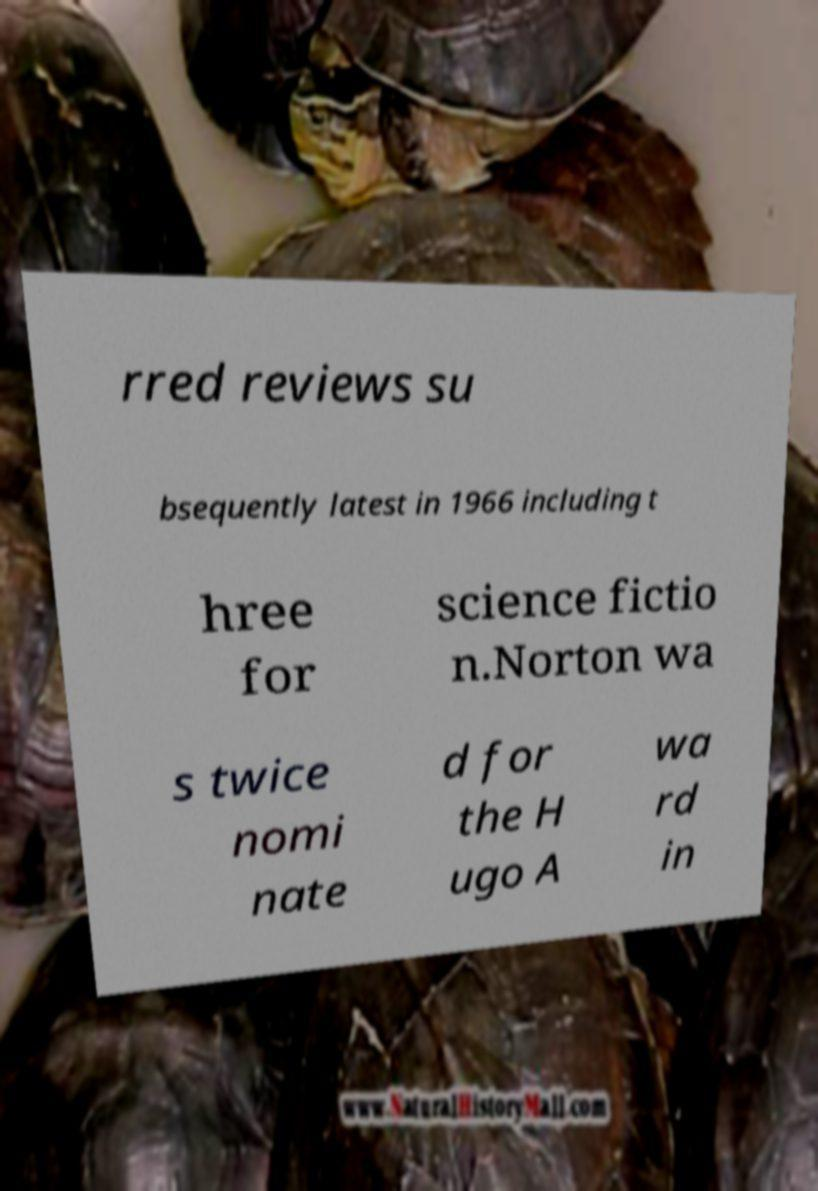Could you extract and type out the text from this image? rred reviews su bsequently latest in 1966 including t hree for science fictio n.Norton wa s twice nomi nate d for the H ugo A wa rd in 